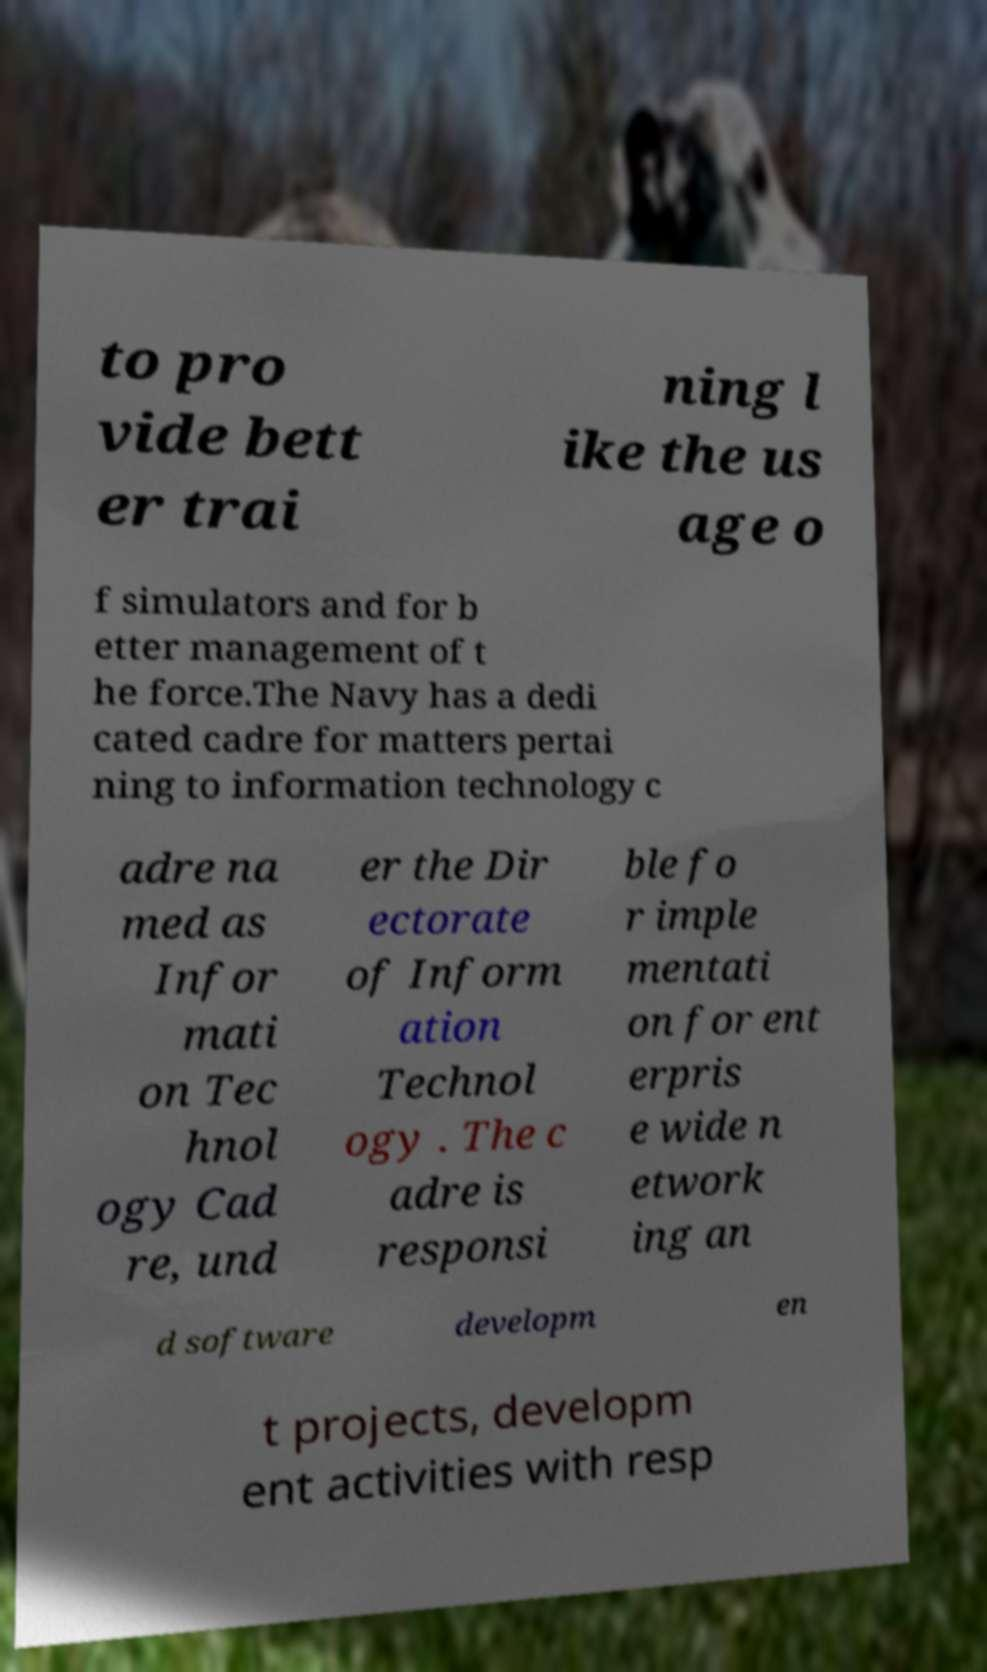What messages or text are displayed in this image? I need them in a readable, typed format. to pro vide bett er trai ning l ike the us age o f simulators and for b etter management of t he force.The Navy has a dedi cated cadre for matters pertai ning to information technology c adre na med as Infor mati on Tec hnol ogy Cad re, und er the Dir ectorate of Inform ation Technol ogy . The c adre is responsi ble fo r imple mentati on for ent erpris e wide n etwork ing an d software developm en t projects, developm ent activities with resp 